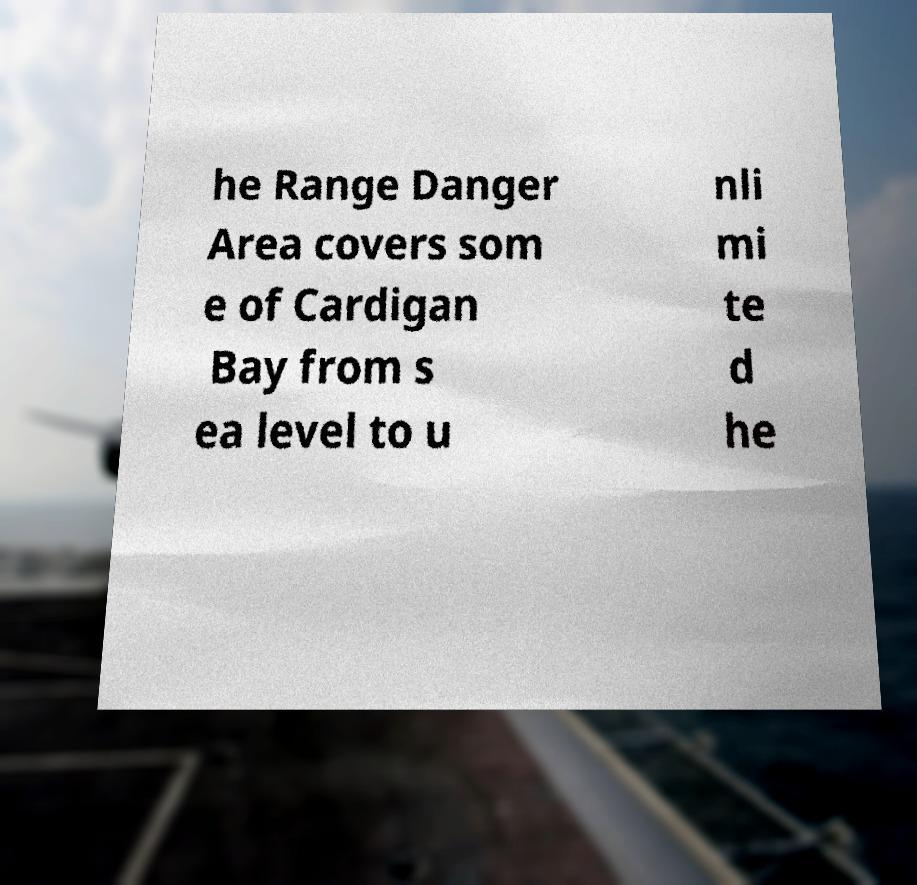Please read and relay the text visible in this image. What does it say? he Range Danger Area covers som e of Cardigan Bay from s ea level to u nli mi te d he 